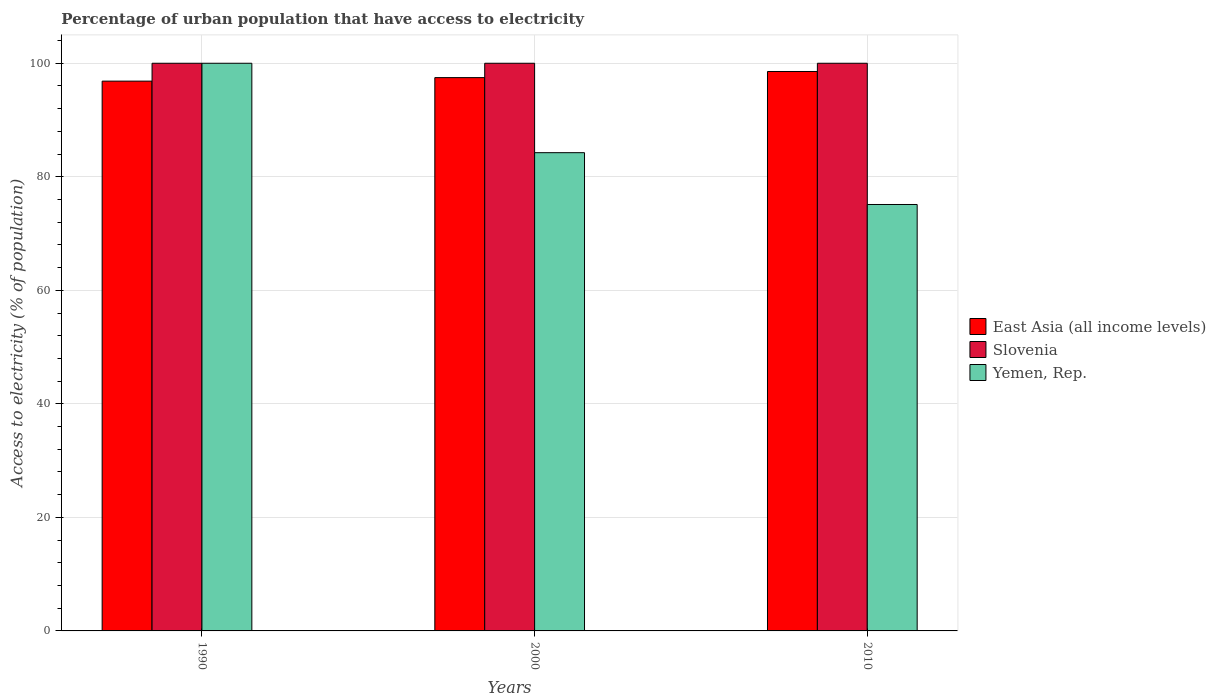How many groups of bars are there?
Make the answer very short. 3. How many bars are there on the 1st tick from the left?
Your answer should be very brief. 3. How many bars are there on the 1st tick from the right?
Keep it short and to the point. 3. What is the label of the 3rd group of bars from the left?
Provide a succinct answer. 2010. What is the percentage of urban population that have access to electricity in Yemen, Rep. in 2000?
Give a very brief answer. 84.25. Across all years, what is the maximum percentage of urban population that have access to electricity in Slovenia?
Your answer should be very brief. 100. Across all years, what is the minimum percentage of urban population that have access to electricity in East Asia (all income levels)?
Make the answer very short. 96.85. What is the total percentage of urban population that have access to electricity in East Asia (all income levels) in the graph?
Offer a terse response. 292.87. What is the difference between the percentage of urban population that have access to electricity in Yemen, Rep. in 2000 and that in 2010?
Give a very brief answer. 9.13. What is the difference between the percentage of urban population that have access to electricity in Yemen, Rep. in 2000 and the percentage of urban population that have access to electricity in Slovenia in 2010?
Keep it short and to the point. -15.75. In the year 2010, what is the difference between the percentage of urban population that have access to electricity in East Asia (all income levels) and percentage of urban population that have access to electricity in Yemen, Rep.?
Offer a very short reply. 23.43. What is the ratio of the percentage of urban population that have access to electricity in East Asia (all income levels) in 1990 to that in 2000?
Offer a very short reply. 0.99. Is the percentage of urban population that have access to electricity in East Asia (all income levels) in 1990 less than that in 2010?
Keep it short and to the point. Yes. What is the difference between the highest and the second highest percentage of urban population that have access to electricity in Yemen, Rep.?
Keep it short and to the point. 15.75. Is the sum of the percentage of urban population that have access to electricity in Yemen, Rep. in 2000 and 2010 greater than the maximum percentage of urban population that have access to electricity in East Asia (all income levels) across all years?
Ensure brevity in your answer.  Yes. What does the 1st bar from the left in 1990 represents?
Provide a succinct answer. East Asia (all income levels). What does the 2nd bar from the right in 1990 represents?
Ensure brevity in your answer.  Slovenia. What is the difference between two consecutive major ticks on the Y-axis?
Make the answer very short. 20. Does the graph contain any zero values?
Offer a terse response. No. Does the graph contain grids?
Offer a very short reply. Yes. How are the legend labels stacked?
Give a very brief answer. Vertical. What is the title of the graph?
Keep it short and to the point. Percentage of urban population that have access to electricity. Does "Trinidad and Tobago" appear as one of the legend labels in the graph?
Give a very brief answer. No. What is the label or title of the X-axis?
Keep it short and to the point. Years. What is the label or title of the Y-axis?
Your answer should be very brief. Access to electricity (% of population). What is the Access to electricity (% of population) in East Asia (all income levels) in 1990?
Offer a very short reply. 96.85. What is the Access to electricity (% of population) of Slovenia in 1990?
Provide a succinct answer. 100. What is the Access to electricity (% of population) of East Asia (all income levels) in 2000?
Give a very brief answer. 97.47. What is the Access to electricity (% of population) of Yemen, Rep. in 2000?
Ensure brevity in your answer.  84.25. What is the Access to electricity (% of population) in East Asia (all income levels) in 2010?
Your response must be concise. 98.55. What is the Access to electricity (% of population) in Slovenia in 2010?
Offer a very short reply. 100. What is the Access to electricity (% of population) of Yemen, Rep. in 2010?
Provide a short and direct response. 75.12. Across all years, what is the maximum Access to electricity (% of population) in East Asia (all income levels)?
Ensure brevity in your answer.  98.55. Across all years, what is the maximum Access to electricity (% of population) in Yemen, Rep.?
Provide a succinct answer. 100. Across all years, what is the minimum Access to electricity (% of population) of East Asia (all income levels)?
Your answer should be compact. 96.85. Across all years, what is the minimum Access to electricity (% of population) of Slovenia?
Offer a very short reply. 100. Across all years, what is the minimum Access to electricity (% of population) of Yemen, Rep.?
Make the answer very short. 75.12. What is the total Access to electricity (% of population) in East Asia (all income levels) in the graph?
Give a very brief answer. 292.87. What is the total Access to electricity (% of population) of Slovenia in the graph?
Your answer should be very brief. 300. What is the total Access to electricity (% of population) of Yemen, Rep. in the graph?
Provide a succinct answer. 259.37. What is the difference between the Access to electricity (% of population) of East Asia (all income levels) in 1990 and that in 2000?
Keep it short and to the point. -0.62. What is the difference between the Access to electricity (% of population) of Yemen, Rep. in 1990 and that in 2000?
Offer a very short reply. 15.75. What is the difference between the Access to electricity (% of population) in East Asia (all income levels) in 1990 and that in 2010?
Provide a succinct answer. -1.7. What is the difference between the Access to electricity (% of population) of Yemen, Rep. in 1990 and that in 2010?
Provide a short and direct response. 24.88. What is the difference between the Access to electricity (% of population) in East Asia (all income levels) in 2000 and that in 2010?
Your answer should be very brief. -1.08. What is the difference between the Access to electricity (% of population) in Yemen, Rep. in 2000 and that in 2010?
Ensure brevity in your answer.  9.13. What is the difference between the Access to electricity (% of population) of East Asia (all income levels) in 1990 and the Access to electricity (% of population) of Slovenia in 2000?
Your answer should be compact. -3.15. What is the difference between the Access to electricity (% of population) in East Asia (all income levels) in 1990 and the Access to electricity (% of population) in Yemen, Rep. in 2000?
Offer a terse response. 12.6. What is the difference between the Access to electricity (% of population) of Slovenia in 1990 and the Access to electricity (% of population) of Yemen, Rep. in 2000?
Make the answer very short. 15.75. What is the difference between the Access to electricity (% of population) in East Asia (all income levels) in 1990 and the Access to electricity (% of population) in Slovenia in 2010?
Provide a short and direct response. -3.15. What is the difference between the Access to electricity (% of population) in East Asia (all income levels) in 1990 and the Access to electricity (% of population) in Yemen, Rep. in 2010?
Your answer should be very brief. 21.73. What is the difference between the Access to electricity (% of population) of Slovenia in 1990 and the Access to electricity (% of population) of Yemen, Rep. in 2010?
Your answer should be compact. 24.88. What is the difference between the Access to electricity (% of population) of East Asia (all income levels) in 2000 and the Access to electricity (% of population) of Slovenia in 2010?
Offer a terse response. -2.53. What is the difference between the Access to electricity (% of population) of East Asia (all income levels) in 2000 and the Access to electricity (% of population) of Yemen, Rep. in 2010?
Your answer should be compact. 22.35. What is the difference between the Access to electricity (% of population) in Slovenia in 2000 and the Access to electricity (% of population) in Yemen, Rep. in 2010?
Provide a short and direct response. 24.88. What is the average Access to electricity (% of population) in East Asia (all income levels) per year?
Make the answer very short. 97.62. What is the average Access to electricity (% of population) of Yemen, Rep. per year?
Keep it short and to the point. 86.46. In the year 1990, what is the difference between the Access to electricity (% of population) in East Asia (all income levels) and Access to electricity (% of population) in Slovenia?
Offer a very short reply. -3.15. In the year 1990, what is the difference between the Access to electricity (% of population) in East Asia (all income levels) and Access to electricity (% of population) in Yemen, Rep.?
Keep it short and to the point. -3.15. In the year 2000, what is the difference between the Access to electricity (% of population) of East Asia (all income levels) and Access to electricity (% of population) of Slovenia?
Give a very brief answer. -2.53. In the year 2000, what is the difference between the Access to electricity (% of population) of East Asia (all income levels) and Access to electricity (% of population) of Yemen, Rep.?
Provide a succinct answer. 13.22. In the year 2000, what is the difference between the Access to electricity (% of population) of Slovenia and Access to electricity (% of population) of Yemen, Rep.?
Give a very brief answer. 15.75. In the year 2010, what is the difference between the Access to electricity (% of population) of East Asia (all income levels) and Access to electricity (% of population) of Slovenia?
Offer a very short reply. -1.45. In the year 2010, what is the difference between the Access to electricity (% of population) in East Asia (all income levels) and Access to electricity (% of population) in Yemen, Rep.?
Your response must be concise. 23.43. In the year 2010, what is the difference between the Access to electricity (% of population) of Slovenia and Access to electricity (% of population) of Yemen, Rep.?
Provide a succinct answer. 24.88. What is the ratio of the Access to electricity (% of population) of Yemen, Rep. in 1990 to that in 2000?
Your answer should be very brief. 1.19. What is the ratio of the Access to electricity (% of population) in East Asia (all income levels) in 1990 to that in 2010?
Offer a terse response. 0.98. What is the ratio of the Access to electricity (% of population) in Slovenia in 1990 to that in 2010?
Your response must be concise. 1. What is the ratio of the Access to electricity (% of population) in Yemen, Rep. in 1990 to that in 2010?
Your answer should be compact. 1.33. What is the ratio of the Access to electricity (% of population) of East Asia (all income levels) in 2000 to that in 2010?
Keep it short and to the point. 0.99. What is the ratio of the Access to electricity (% of population) of Yemen, Rep. in 2000 to that in 2010?
Offer a very short reply. 1.12. What is the difference between the highest and the second highest Access to electricity (% of population) of East Asia (all income levels)?
Your answer should be very brief. 1.08. What is the difference between the highest and the second highest Access to electricity (% of population) of Slovenia?
Make the answer very short. 0. What is the difference between the highest and the second highest Access to electricity (% of population) in Yemen, Rep.?
Offer a very short reply. 15.75. What is the difference between the highest and the lowest Access to electricity (% of population) in East Asia (all income levels)?
Keep it short and to the point. 1.7. What is the difference between the highest and the lowest Access to electricity (% of population) of Slovenia?
Give a very brief answer. 0. What is the difference between the highest and the lowest Access to electricity (% of population) of Yemen, Rep.?
Provide a short and direct response. 24.88. 